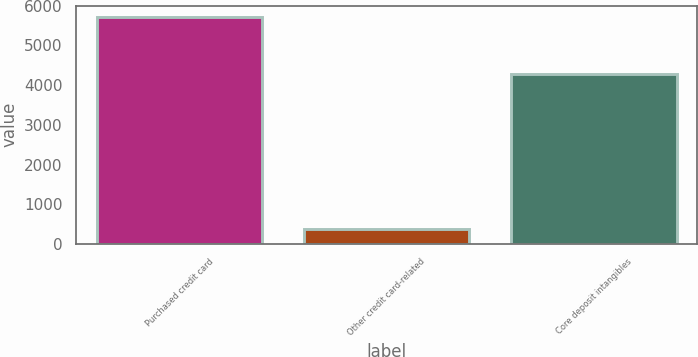Convert chart. <chart><loc_0><loc_0><loc_500><loc_500><bar_chart><fcel>Purchased credit card<fcel>Other credit card-related<fcel>Core deposit intangibles<nl><fcel>5716<fcel>367<fcel>4283<nl></chart> 